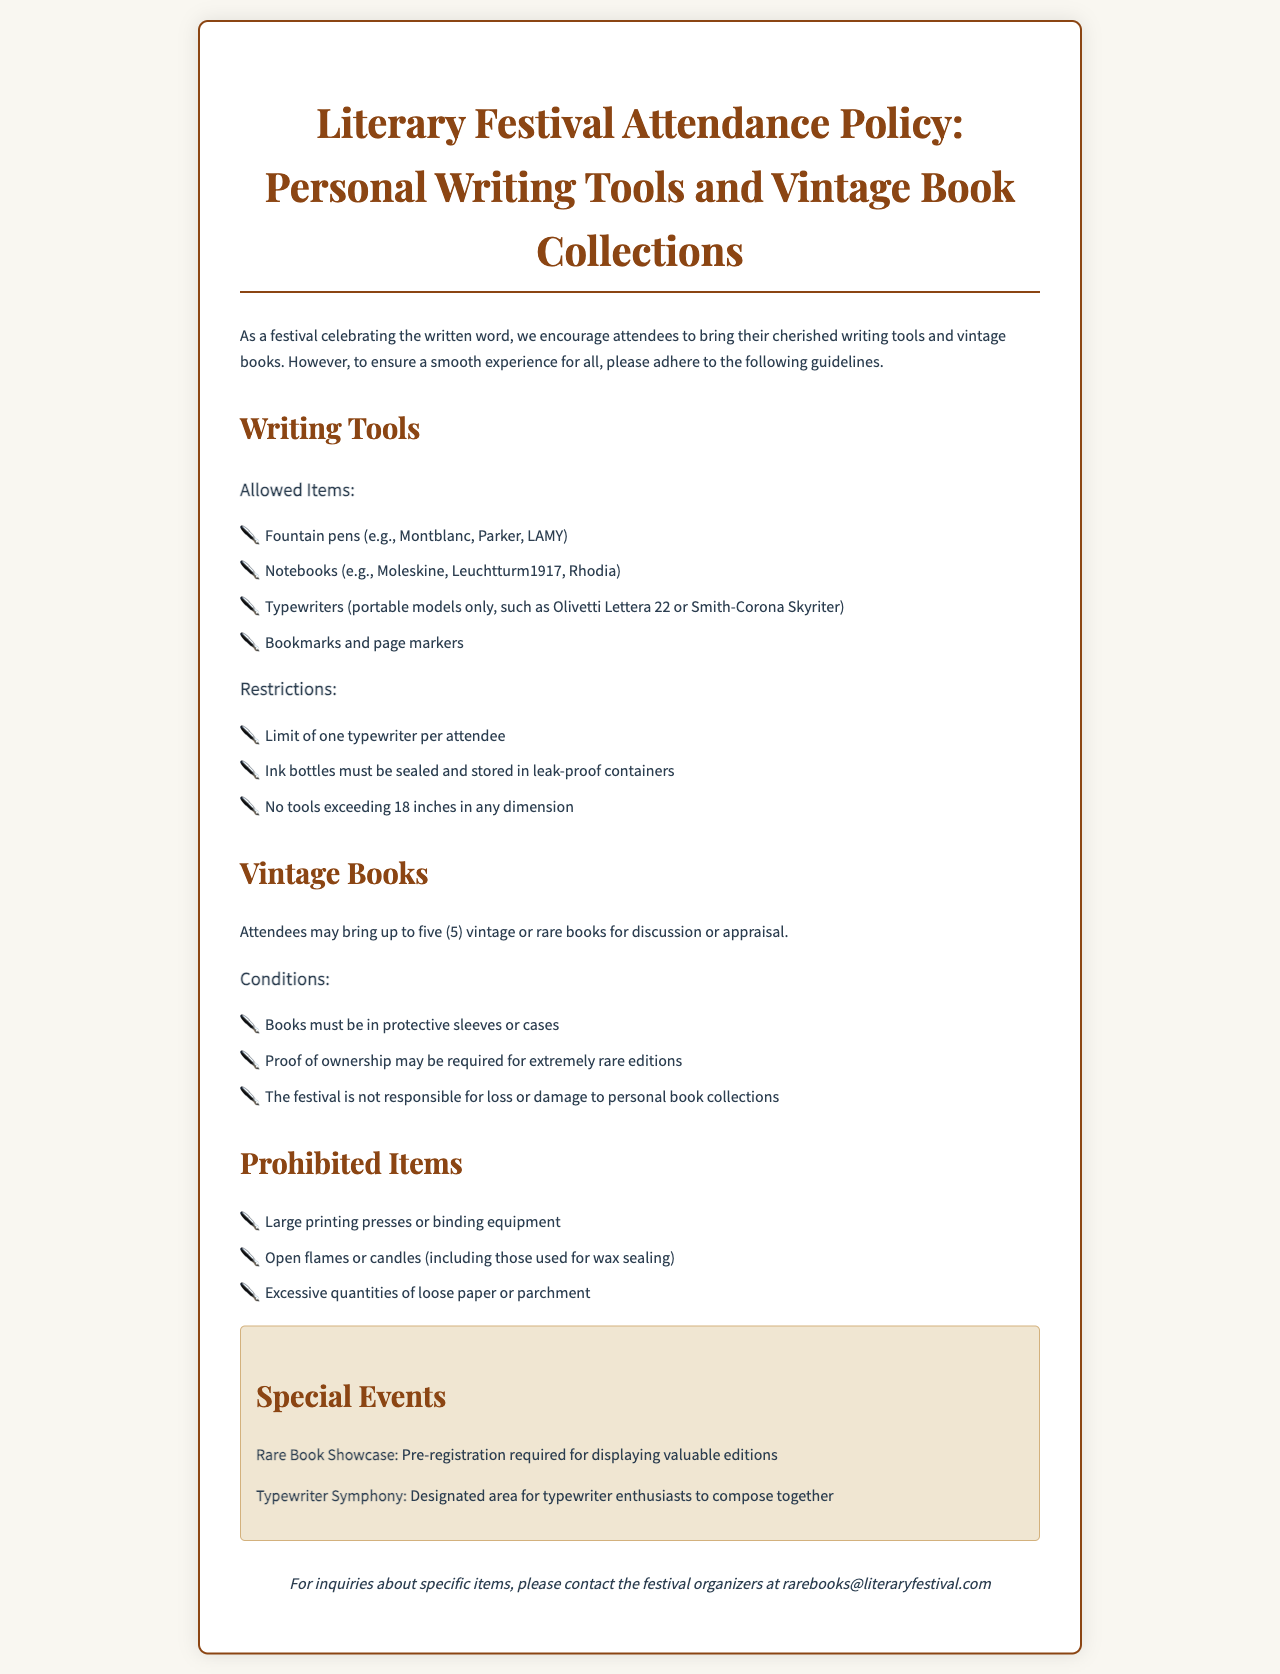What are the allowed writing tools? The document lists specific items that are allowed as writing tools for attendees, including fountain pens, notebooks, typewriters, and bookmarks.
Answer: Fountain pens, notebooks, typewriters, bookmarks What is the limit on typewriters per attendee? The document specifies a restriction regarding the number of typewriters a single attendee can bring, which is one typewriter.
Answer: One typewriter How many vintage books can attendees bring? The policy mentions a specific quantity that attendees are allowed to bring for discussion or appraisal, which is five.
Answer: Five What is required for extremely rare books? The document states that proof of ownership may be required for extremely rare book editions to ensure authenticity.
Answer: Proof of ownership What is the festival's responsibility regarding personal book collections? The policy clearly articulates the festival's stance on responsibility for attendees' personal property, emphasizing they are not responsible for loss or damage.
Answer: The festival is not responsible for loss or damage What are the prohibited items at the festival? The document outlines specific items that are not permitted at the festival, which include large printing presses and open flames.
Answer: Large printing presses or binding equipment, open flames or candles, excessive quantities of loose paper What special event requires pre-registration? The document mentions a specific event that requires attendees to pre-register if they want to display valuable editions, which is the Rare Book Showcase.
Answer: Rare Book Showcase What type of event is the Typewriter Symphony? The document describes a designated area for typewriter enthusiasts to come together and create, characterizing this event.
Answer: Designated area for typewriter enthusiasts to compose together What should ink bottles be stored in? The policy outlines a specific requirement regarding the storage of ink bottles for safety and cleanliness, which is leak-proof containers.
Answer: Leak-proof containers 